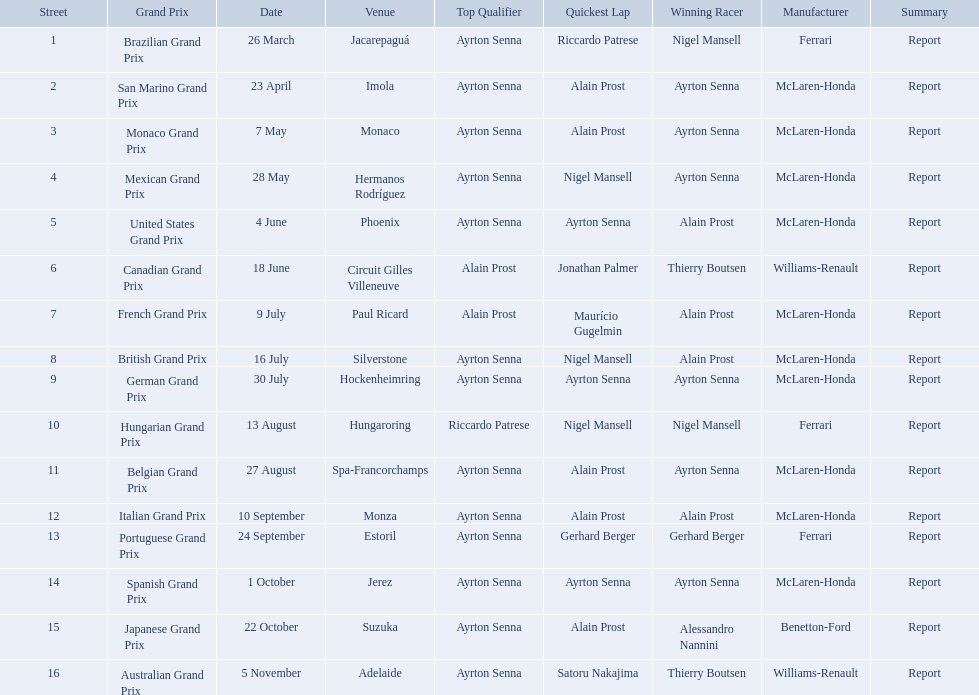Who are the constructors in the 1989 formula one season? Ferrari, McLaren-Honda, McLaren-Honda, McLaren-Honda, McLaren-Honda, Williams-Renault, McLaren-Honda, McLaren-Honda, McLaren-Honda, Ferrari, McLaren-Honda, McLaren-Honda, Ferrari, McLaren-Honda, Benetton-Ford, Williams-Renault. On what date was bennington ford the constructor? 22 October. What was the race on october 22? Japanese Grand Prix. Who won the spanish grand prix? McLaren-Honda. Who won the italian grand prix? McLaren-Honda. What grand prix did benneton-ford win? Japanese Grand Prix. Can you parse all the data within this table? {'header': ['Street', 'Grand Prix', 'Date', 'Venue', 'Top Qualifier', 'Quickest Lap', 'Winning Racer', 'Manufacturer', 'Summary'], 'rows': [['1', 'Brazilian Grand Prix', '26 March', 'Jacarepaguá', 'Ayrton Senna', 'Riccardo Patrese', 'Nigel Mansell', 'Ferrari', 'Report'], ['2', 'San Marino Grand Prix', '23 April', 'Imola', 'Ayrton Senna', 'Alain Prost', 'Ayrton Senna', 'McLaren-Honda', 'Report'], ['3', 'Monaco Grand Prix', '7 May', 'Monaco', 'Ayrton Senna', 'Alain Prost', 'Ayrton Senna', 'McLaren-Honda', 'Report'], ['4', 'Mexican Grand Prix', '28 May', 'Hermanos Rodríguez', 'Ayrton Senna', 'Nigel Mansell', 'Ayrton Senna', 'McLaren-Honda', 'Report'], ['5', 'United States Grand Prix', '4 June', 'Phoenix', 'Ayrton Senna', 'Ayrton Senna', 'Alain Prost', 'McLaren-Honda', 'Report'], ['6', 'Canadian Grand Prix', '18 June', 'Circuit Gilles Villeneuve', 'Alain Prost', 'Jonathan Palmer', 'Thierry Boutsen', 'Williams-Renault', 'Report'], ['7', 'French Grand Prix', '9 July', 'Paul Ricard', 'Alain Prost', 'Maurício Gugelmin', 'Alain Prost', 'McLaren-Honda', 'Report'], ['8', 'British Grand Prix', '16 July', 'Silverstone', 'Ayrton Senna', 'Nigel Mansell', 'Alain Prost', 'McLaren-Honda', 'Report'], ['9', 'German Grand Prix', '30 July', 'Hockenheimring', 'Ayrton Senna', 'Ayrton Senna', 'Ayrton Senna', 'McLaren-Honda', 'Report'], ['10', 'Hungarian Grand Prix', '13 August', 'Hungaroring', 'Riccardo Patrese', 'Nigel Mansell', 'Nigel Mansell', 'Ferrari', 'Report'], ['11', 'Belgian Grand Prix', '27 August', 'Spa-Francorchamps', 'Ayrton Senna', 'Alain Prost', 'Ayrton Senna', 'McLaren-Honda', 'Report'], ['12', 'Italian Grand Prix', '10 September', 'Monza', 'Ayrton Senna', 'Alain Prost', 'Alain Prost', 'McLaren-Honda', 'Report'], ['13', 'Portuguese Grand Prix', '24 September', 'Estoril', 'Ayrton Senna', 'Gerhard Berger', 'Gerhard Berger', 'Ferrari', 'Report'], ['14', 'Spanish Grand Prix', '1 October', 'Jerez', 'Ayrton Senna', 'Ayrton Senna', 'Ayrton Senna', 'McLaren-Honda', 'Report'], ['15', 'Japanese Grand Prix', '22 October', 'Suzuka', 'Ayrton Senna', 'Alain Prost', 'Alessandro Nannini', 'Benetton-Ford', 'Report'], ['16', 'Australian Grand Prix', '5 November', 'Adelaide', 'Ayrton Senna', 'Satoru Nakajima', 'Thierry Boutsen', 'Williams-Renault', 'Report']]} What are all of the grand prix run in the 1989 formula one season? Brazilian Grand Prix, San Marino Grand Prix, Monaco Grand Prix, Mexican Grand Prix, United States Grand Prix, Canadian Grand Prix, French Grand Prix, British Grand Prix, German Grand Prix, Hungarian Grand Prix, Belgian Grand Prix, Italian Grand Prix, Portuguese Grand Prix, Spanish Grand Prix, Japanese Grand Prix, Australian Grand Prix. Of those 1989 formula one grand prix, which were run in october? Spanish Grand Prix, Japanese Grand Prix, Australian Grand Prix. Of those 1989 formula one grand prix run in october, which was the only one to be won by benetton-ford? Japanese Grand Prix. 